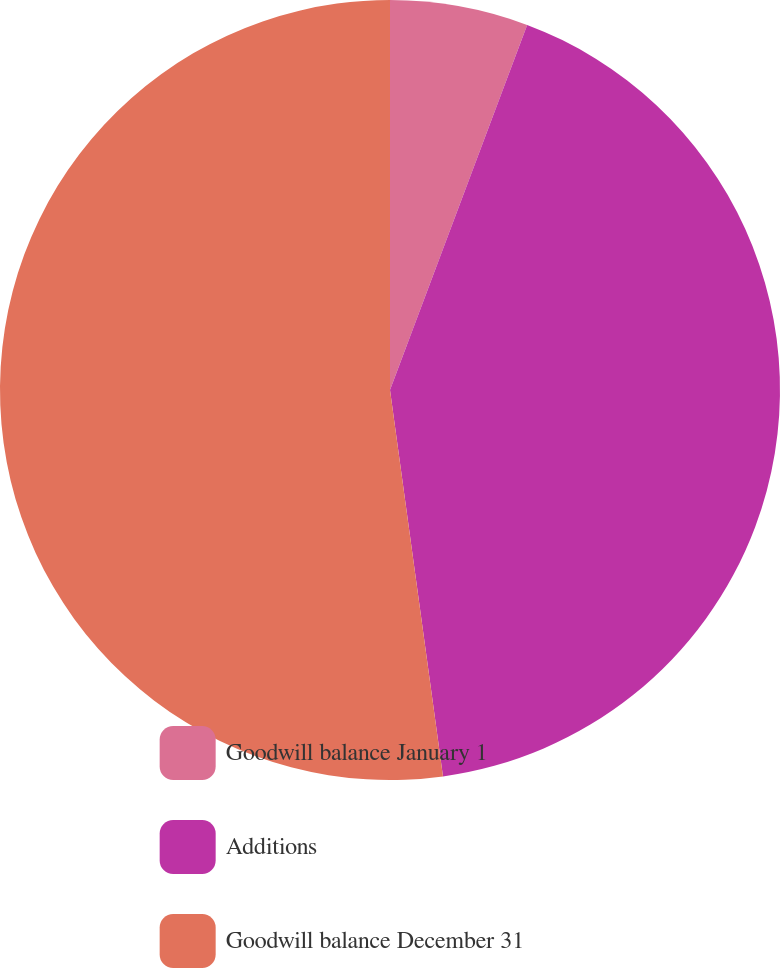<chart> <loc_0><loc_0><loc_500><loc_500><pie_chart><fcel>Goodwill balance January 1<fcel>Additions<fcel>Goodwill balance December 31<nl><fcel>5.72%<fcel>42.11%<fcel>52.17%<nl></chart> 